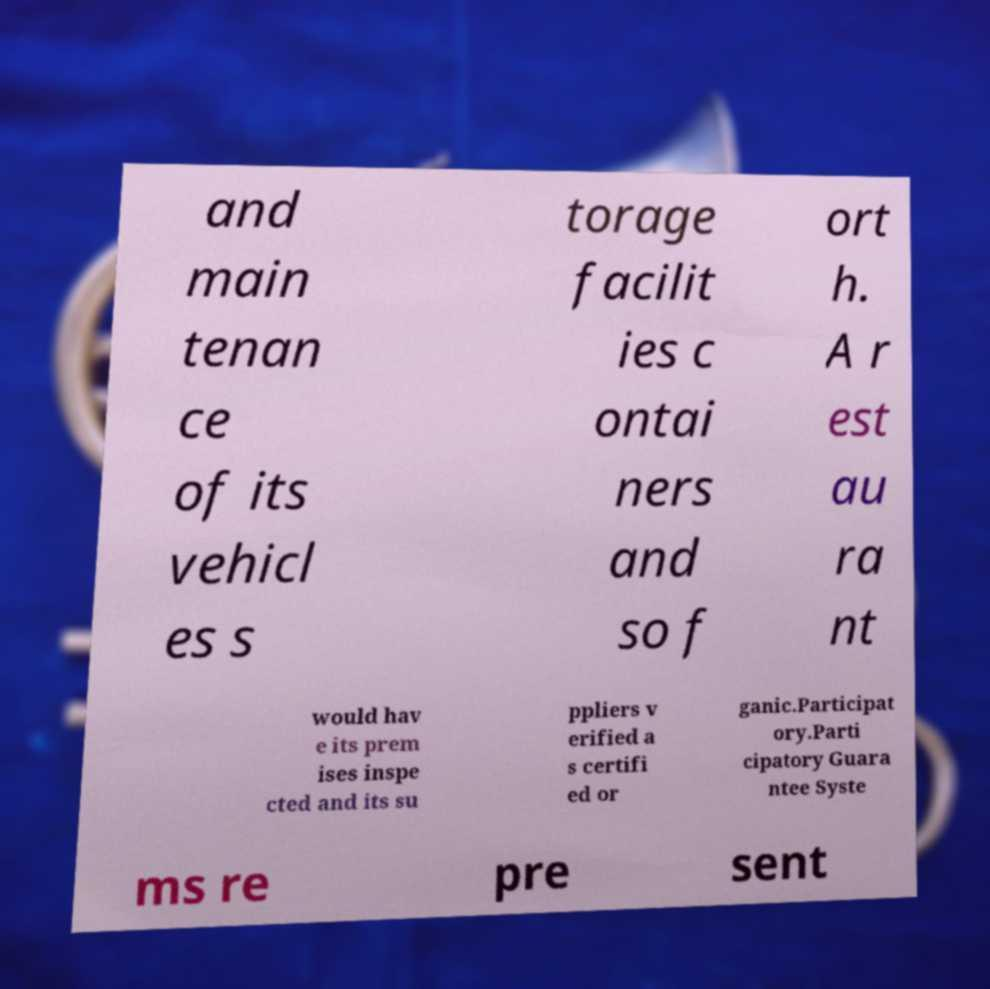Can you read and provide the text displayed in the image?This photo seems to have some interesting text. Can you extract and type it out for me? and main tenan ce of its vehicl es s torage facilit ies c ontai ners and so f ort h. A r est au ra nt would hav e its prem ises inspe cted and its su ppliers v erified a s certifi ed or ganic.Participat ory.Parti cipatory Guara ntee Syste ms re pre sent 